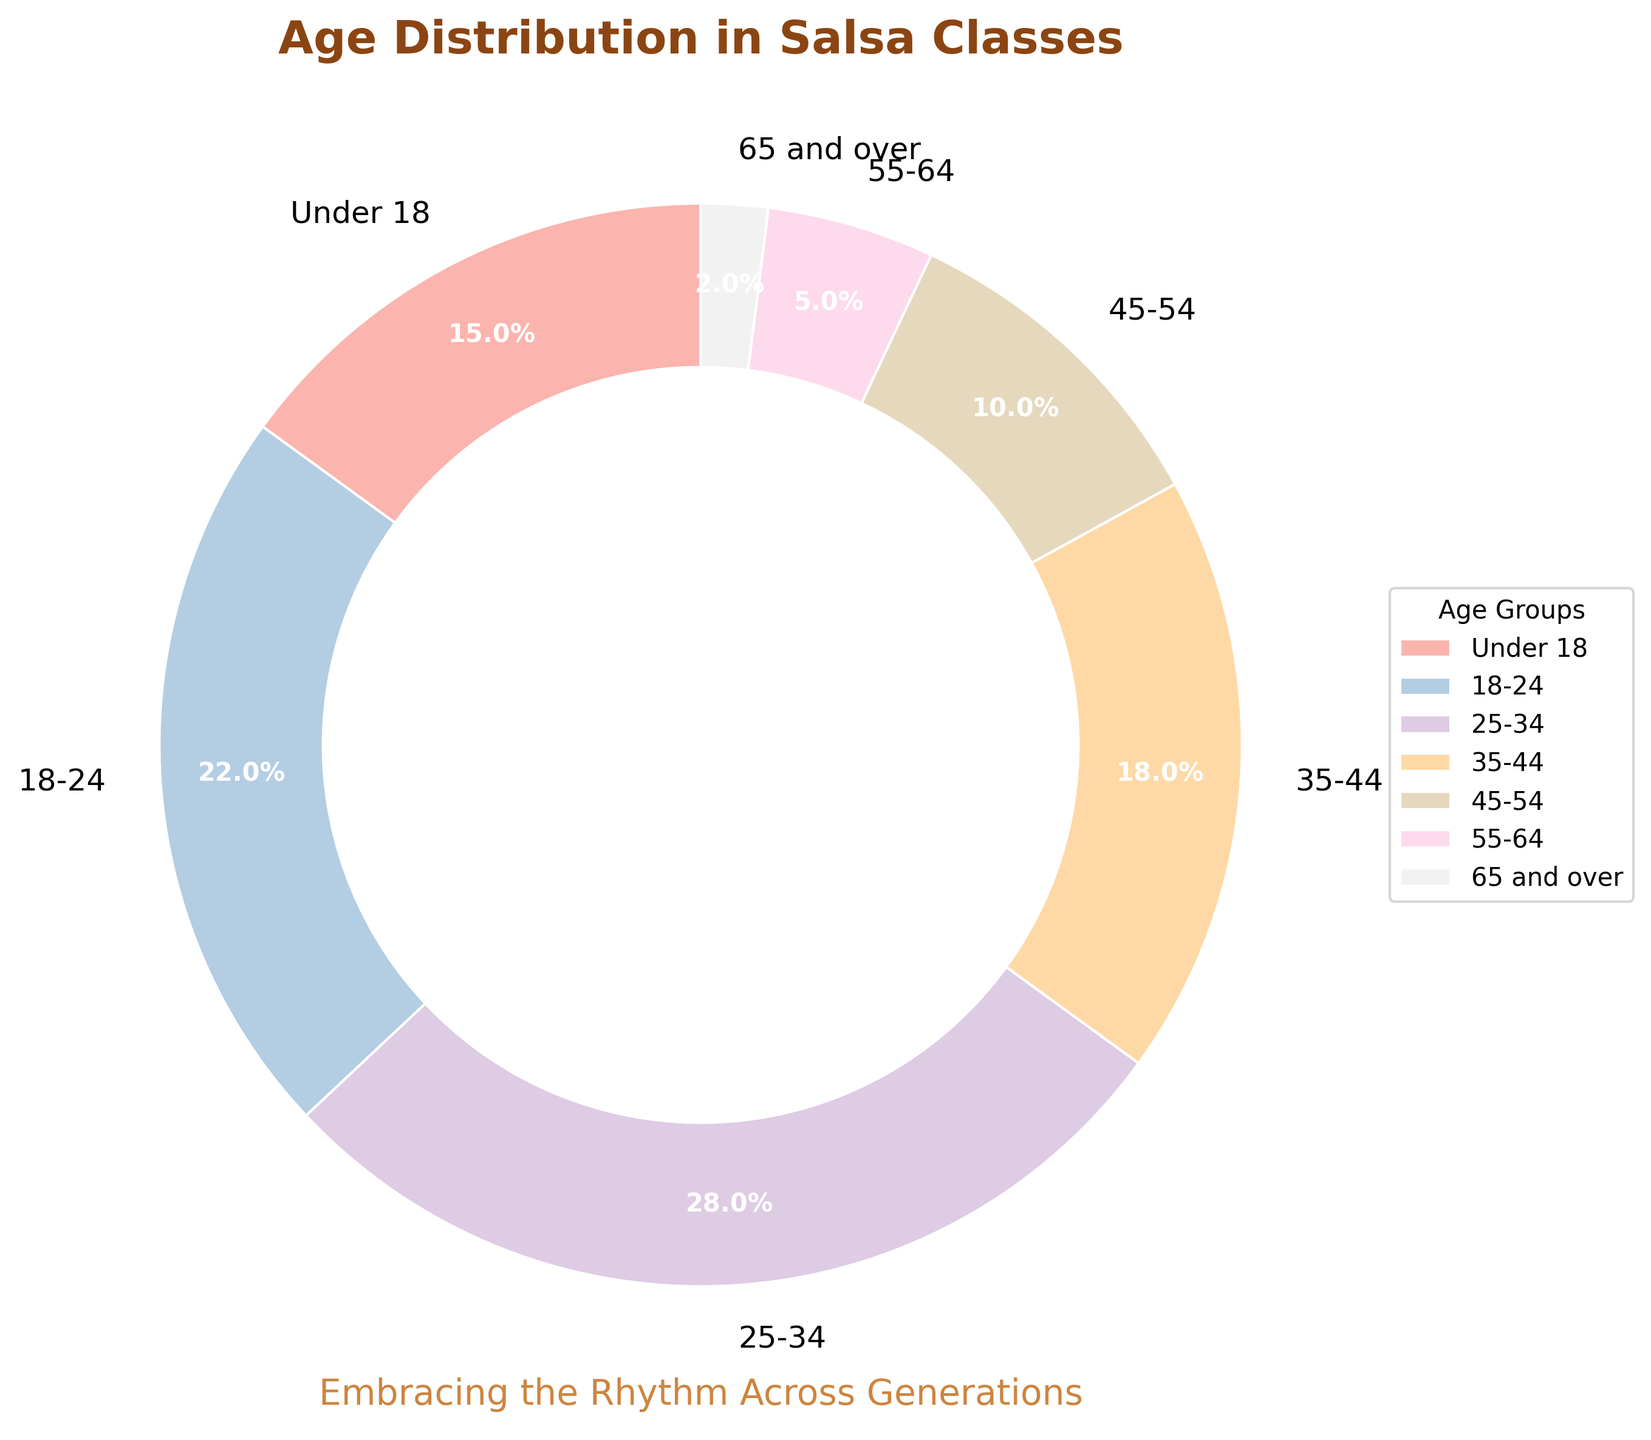What's the smallest age group attending salsa classes? The pie chart shows the percentages for different age groups. The smallest slice corresponds to the "65 and over" age group with 2%.
Answer: 65 and over Which age group has the largest percentage? By looking at the pie chart, the largest segment is labeled "25-34" with 28%.
Answer: 25-34 What is the total percentage of attendees under 25 years old? The under 25 years old group consists of "Under 18" and "18-24". Their percentages are 15% and 22%, respectively. Adding them together gives 15% + 22% = 37%.
Answer: 37% How much larger is the 25-34 age group compared to the 45-54 age group? The pie chart shows "25-34" at 28% and "45-54" at 10%. The difference is 28% - 10% = 18%.
Answer: 18% What percentage of attendees are 55 years and older? The age groups "55-64" and "65 and over" must be summed. Their percentages are 5% and 2%, respectively. Adding them together gives 5% + 2% = 7%.
Answer: 7% Which age groups have a percentage greater than 20%? The pie chart shows that the "18-24" and "25-34" age groups have percentages of 22% and 28%, respectively.
Answer: 18-24 and 25-34 How does the percentage of the 35-44 age group compare to the under 18 age group? The pie chart shows "35-44" at 18% and "Under 18" at 15%, making the "35-44" group 3% higher than the "Under 18" group.
Answer: 3% higher What are the combined percentages of the age groups 35-44 and 45-54? The pie chart shows "35-44" at 18% and "45-54" at 10%. Adding them together gives 18% + 10% = 28%.
Answer: 28% What is the color used for the 18-24 age group in the chart? The "18-24" segment is colored with one of the pastel shades used in the pie chart, typically near the top of the legend. The exact color name is a pastel hue.
Answer: Pastel color (exact hue varies with colormap) How does the percentage of the 45-54 age group compare to the 55-64 age group? The pie chart shows "45-54" at 10% and "55-64" at 5%, making "45-54" double the percentage of "55-64".
Answer: Double 